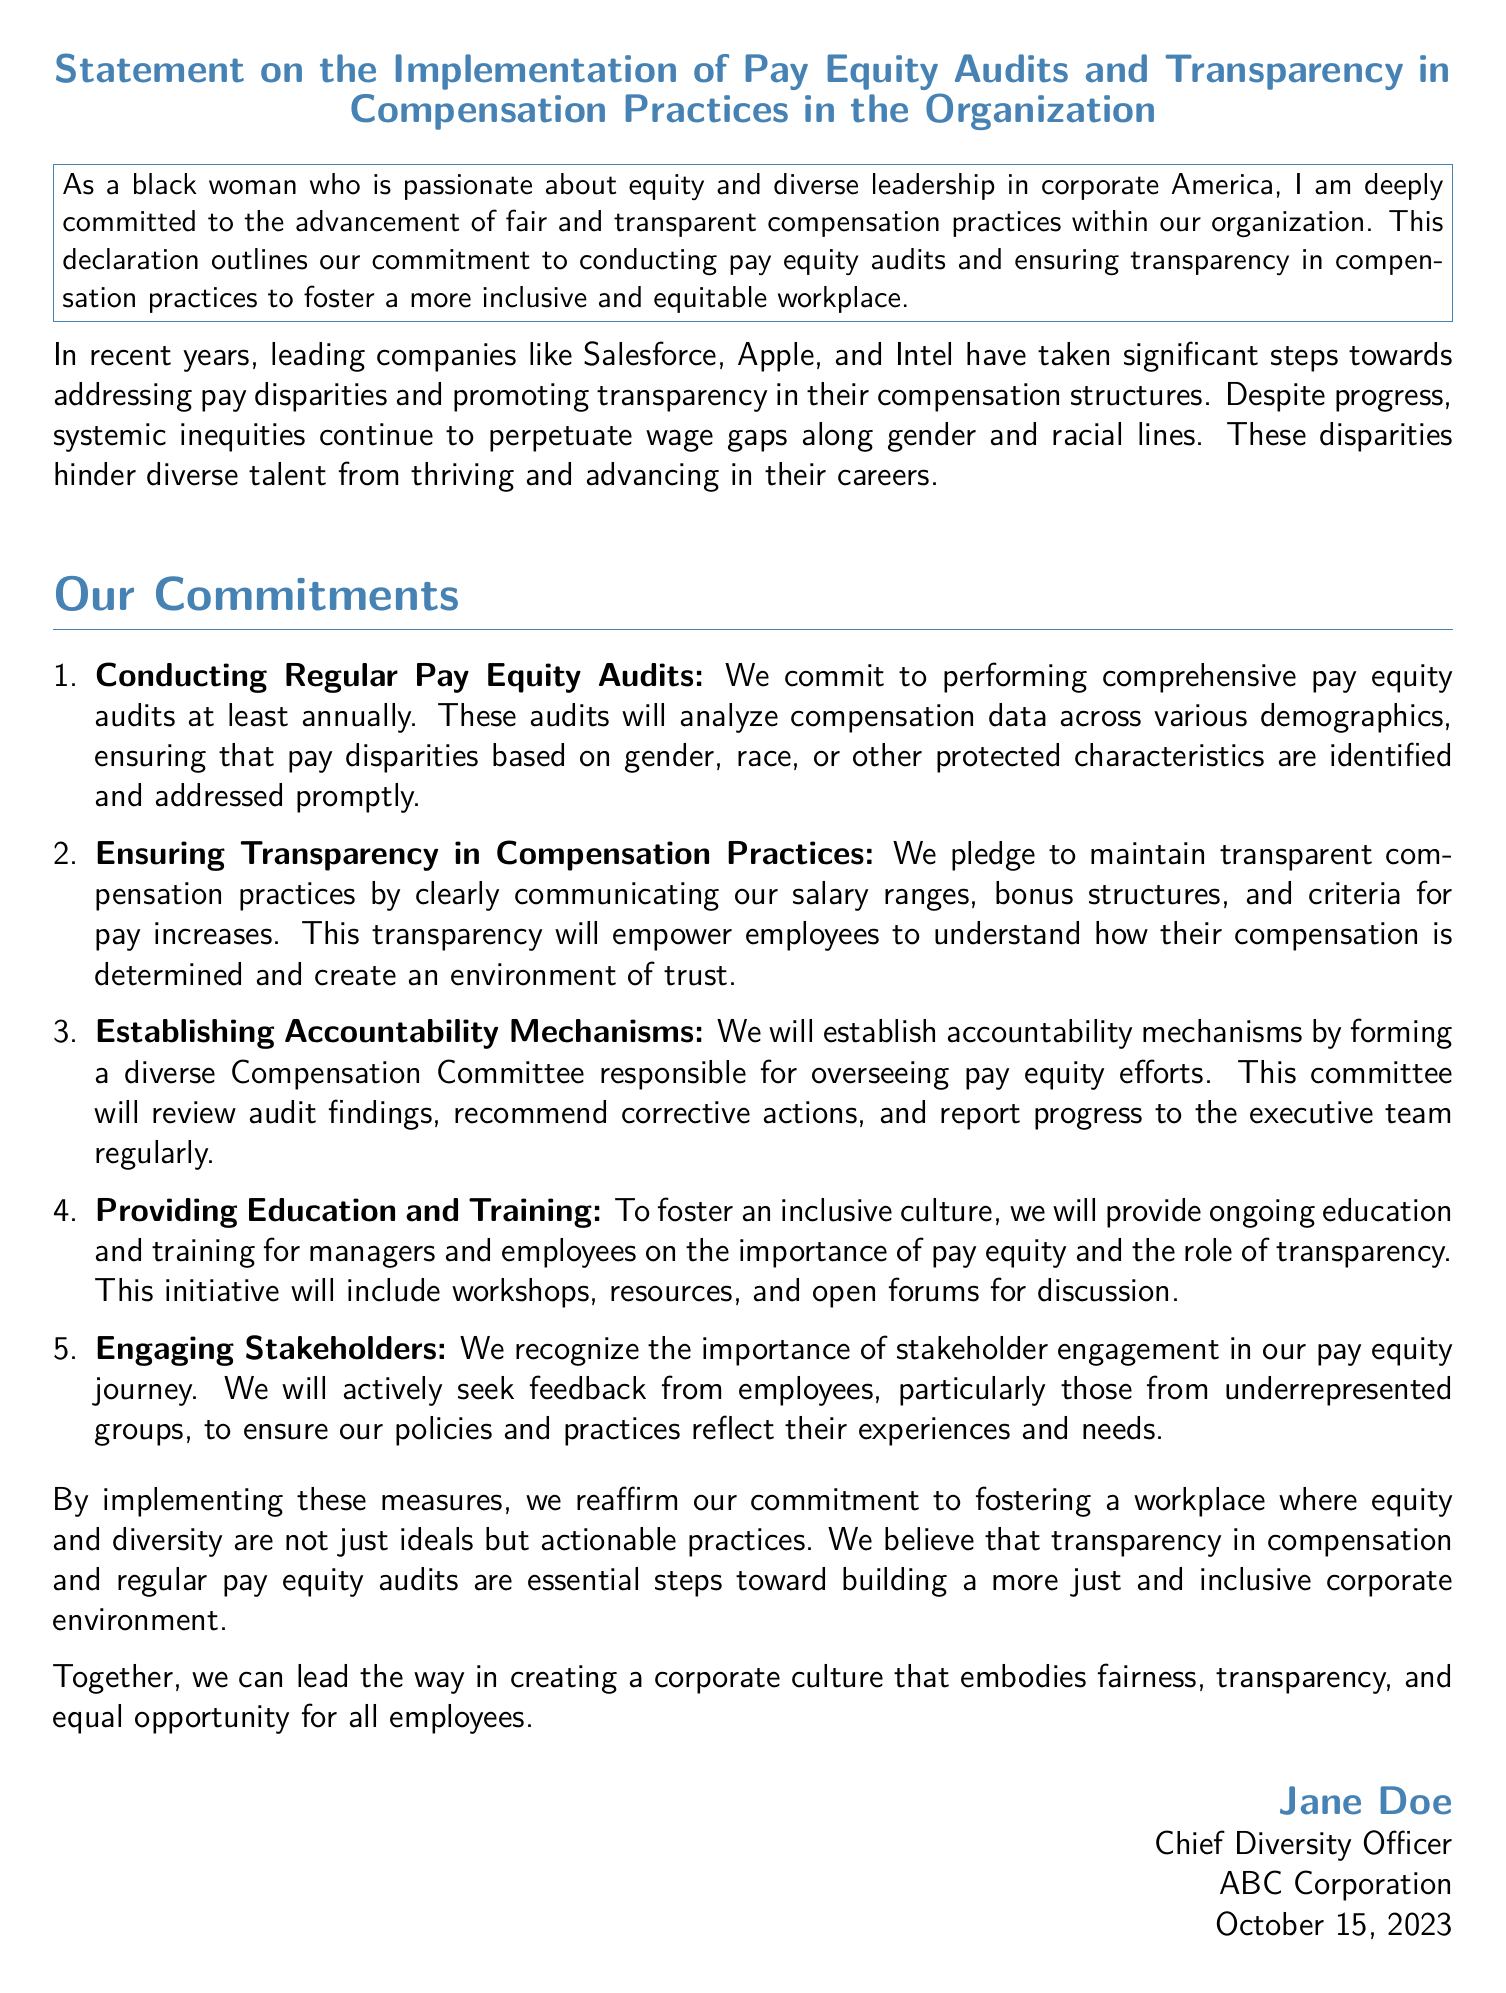What is the title of the document? The title is stated at the top of the document, indicating the main subject it addresses.
Answer: Statement on the Implementation of Pay Equity Audits and Transparency in Compensation Practices in the Organization Who is the author of the declaration? The author is mentioned at the bottom of the document, including their title and organization.
Answer: Jane Doe What is the minimum frequency for conducting pay equity audits according to the document? The document specifies the minimum frequency for these audits, reflecting the commitment to regular assessment of compensation practices.
Answer: annually What is one key commitment outlined in the document? The document lists several commitments aimed at improving equity and transparency in pay, one of which can be identified easily.
Answer: Conducting Regular Pay Equity Audits Which company is mentioned as a leader in addressing pay disparities? The document references specific companies that have made progress in pay equity and transparency, showcasing examples of industry leadership.
Answer: Salesforce What date was this declaration signed? The date of signing is noted at the end of the document, indicating when the commitments were officially made.
Answer: October 15, 2023 What group will oversee pay equity efforts in the organization? The document details the formation of a specific committee tasked with overseeing progress in pay equity, highlighting the structure for accountability.
Answer: Compensation Committee What is one method mentioned for providing education on pay equity? The document describes various methods of education and training aimed at fostering a better understanding of pay equity and transparency within the organization.
Answer: workshops 